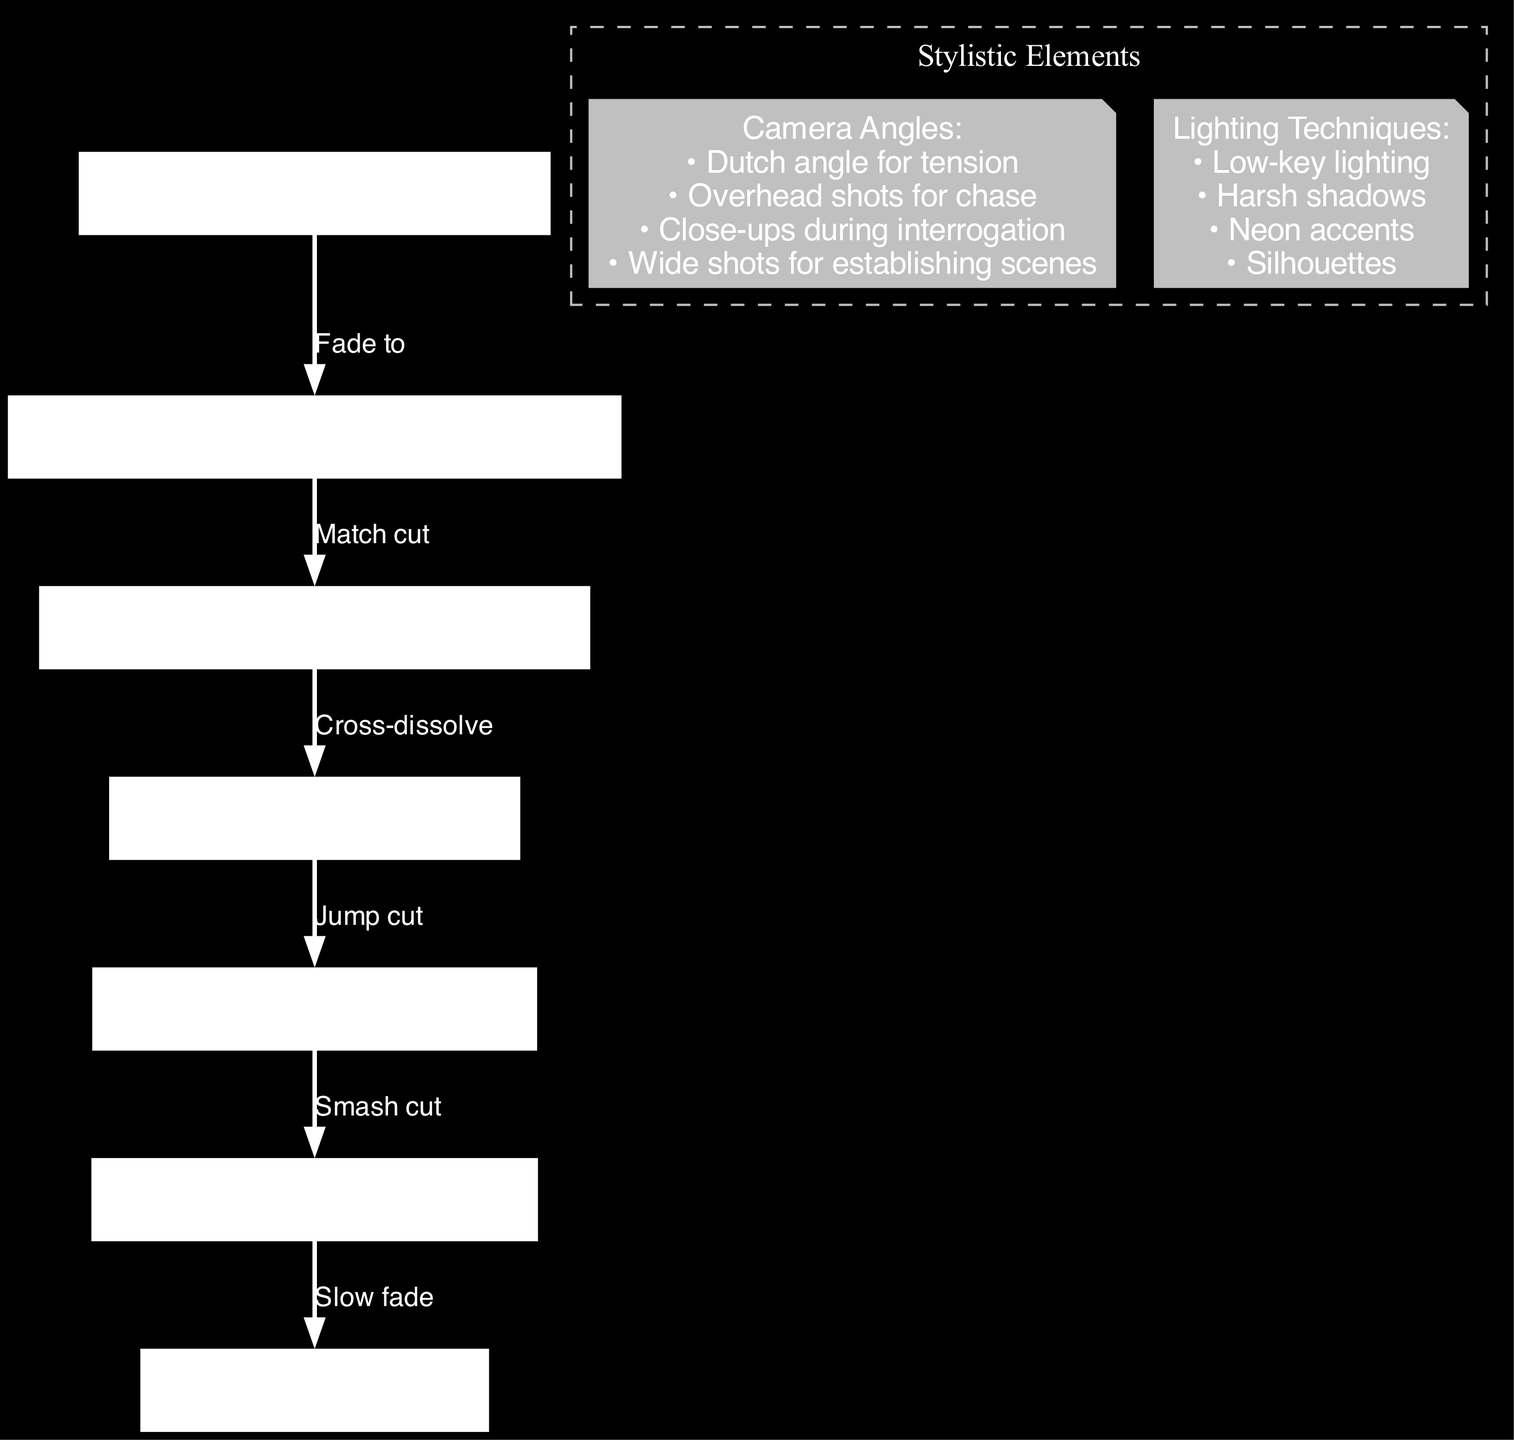What is the label of the first scene in the diagram? The first scene is labeled "Opening Scene: Rainy Alleyway," as it is the first node listed in the data under "nodes."
Answer: Opening Scene: Rainy Alleyway How many transitions are depicted in the diagram? To find the number of transitions, we look at the number of edges listed in the "edges" section, which totals six transitions between different scenes.
Answer: 6 What type of cut is used to transition from the Interrogation scene to the Chase Sequence? The transition from the Interrogation scene to the Chase Sequence is labeled as a "Jump cut," as identified in the edge that connects these two nodes.
Answer: Jump cut What is the last scene before the resolution? The last scene before the resolution is the "Climax: Rooftop Confrontation," as indicated by the edge leading from the climax node to the resolution node.
Answer: Climax: Rooftop Confrontation Which technique is suggested for camera angles during interrogations? For interrogations, the diagram suggests using "Close-ups during interrogation," which is listed under the annotations for camera angles.
Answer: Close-ups during interrogation What lighting technique is specified for creating harsh shadows? The diagram specifies using "Harsh shadows" as a lighting technique, listed under the annotations section regarding lighting techniques.
Answer: Harsh shadows What scene transition is characterized as a "Smash cut"? The scene transition characterized as a "Smash cut" occurs between the "Chase Sequence: City Streets" and the "Climax: Rooftop Confrontation," as described in the edges connecting these nodes.
Answer: Smash cut How many camera angle techniques are mentioned in the annotations? The annotations indicate four different camera angle techniques listed, which include Dutch angle, overhead shots, close-ups, and wide shots.
Answer: 4 Which scene features a cross-dissolve transition? The scene featuring a cross-dissolve transition connects the "Crime Scene: Abandoned Warehouse" to the "Interrogation: Police Station," as noted in the specific edge that connects these nodes.
Answer: Interrogation: Police Station 